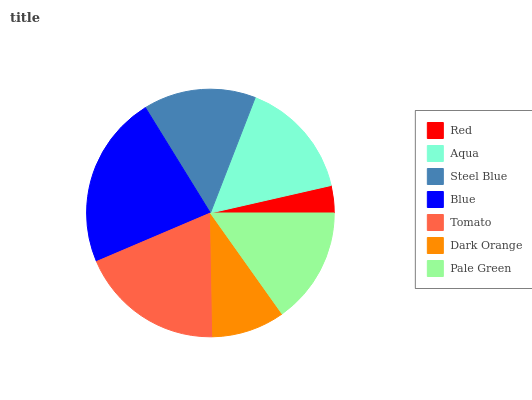Is Red the minimum?
Answer yes or no. Yes. Is Blue the maximum?
Answer yes or no. Yes. Is Aqua the minimum?
Answer yes or no. No. Is Aqua the maximum?
Answer yes or no. No. Is Aqua greater than Red?
Answer yes or no. Yes. Is Red less than Aqua?
Answer yes or no. Yes. Is Red greater than Aqua?
Answer yes or no. No. Is Aqua less than Red?
Answer yes or no. No. Is Pale Green the high median?
Answer yes or no. Yes. Is Pale Green the low median?
Answer yes or no. Yes. Is Steel Blue the high median?
Answer yes or no. No. Is Aqua the low median?
Answer yes or no. No. 